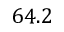<formula> <loc_0><loc_0><loc_500><loc_500>6 4 . 2</formula> 